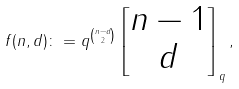<formula> <loc_0><loc_0><loc_500><loc_500>f ( n , d ) \colon = q ^ { \binom { n - d } { 2 } } \begin{bmatrix} n - 1 \\ d \end{bmatrix} _ { q } ,</formula> 